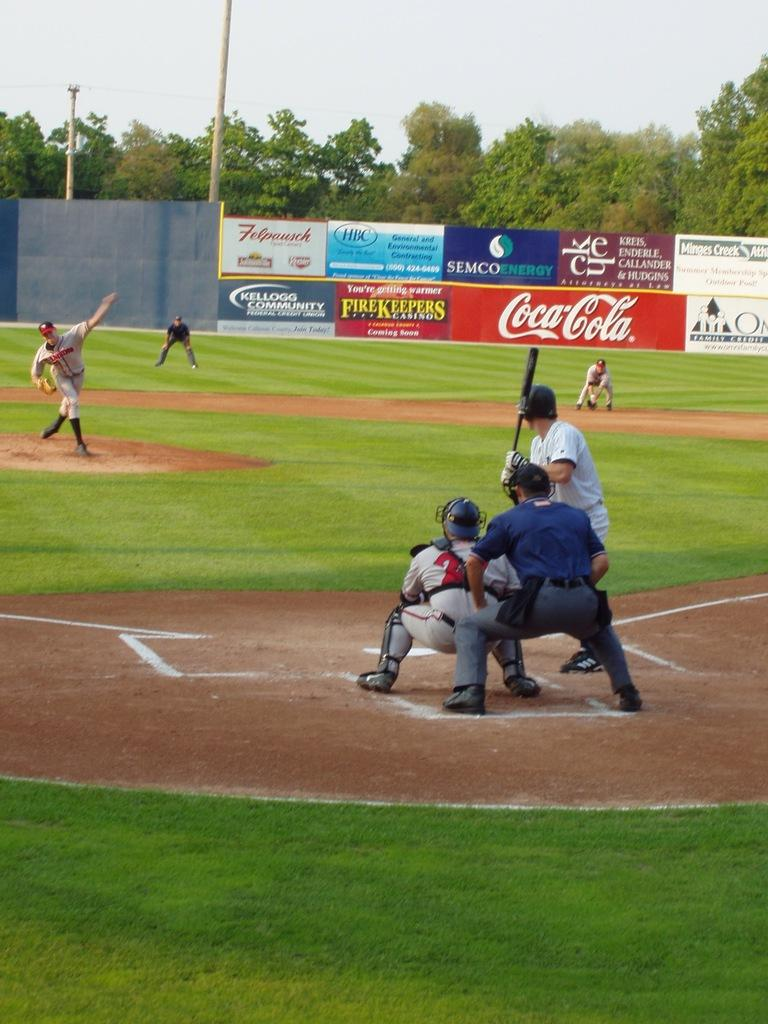<image>
Summarize the visual content of the image. Advertisements for Coca Cola, FireKeepers and Kellogg Community Credit Union are displayed on a baseball diamond's fence. 